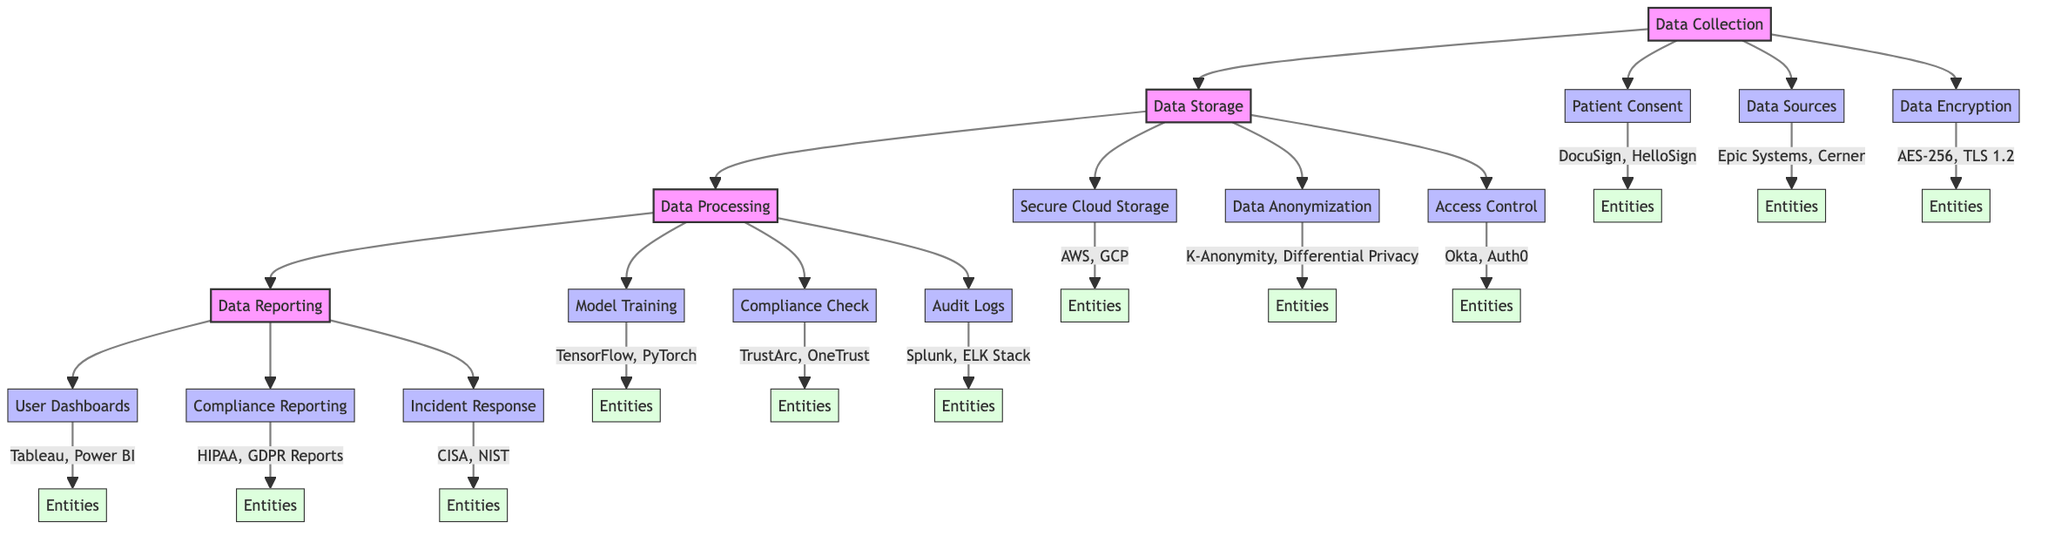What are the major stages in the clinical pathway? The diagram outlines four major stages: Data Collection, Data Storage, Data Processing, and Data Reporting. Each of these stages contributes to the overall data security and compliance processes in AI-enabled mental health platforms.
Answer: Data Collection, Data Storage, Data Processing, Data Reporting How many components are in the Data Processing stage? The Data Processing stage consists of three components: Model Training, Compliance Check, and Audit Logs. This can be determined by counting the components listed under the Data Processing stage in the diagram.
Answer: 3 Which entities are associated with Data Anonymization? The entities associated with Data Anonymization are K-Anonymity and Differential Privacy. This information can be found directly linked to the Data Anonymization component in the diagram.
Answer: K-Anonymity, Differential Privacy What is a primary feature of the Data Encryption component? The Data Encryption component focuses on ensuring encryption of data during transfer and at rest using industry-standard protocols. This descriptive information is directly noted in the diagram under the Data Encryption component.
Answer: Ensure encryption of data during transfer and at rest What follows after Data Storage in the clinical pathway? The next stage that follows Data Storage in the clinical pathway is Data Processing. This can be identified by the flow direction from Data Storage to Data Processing in the diagram.
Answer: Data Processing Which entities are used in the Compliance Check component? The Compliance Check component uses the entities TrustArc and OneTrust. This information is specified next to the Compliance Check node in the diagram.
Answer: TrustArc, OneTrust What does the Incident Response component relate to? The Incident Response component relates to setting up an incident response plan for data breaches or security incidents, with entities CISA and NIST indicated in association with it. This can be deduced from the description and entities linked to the Incident Response component in the diagram.
Answer: Set up an incident response plan for data breaches or security incidents What is implemented in the Data Storage stage to protect patient identity? Data Anonymization is implemented in the Data Storage stage to protect patient identity. This is detailed under the Data Storage stage components in the diagram.
Answer: Data Anonymization How is patient consent obtained in the Data Collection stage? Patient consent is obtained securely using electronic consent forms, as described in the Patient Consent component's description in the diagram.
Answer: Securely obtain and document patient consent using electronic consent forms 